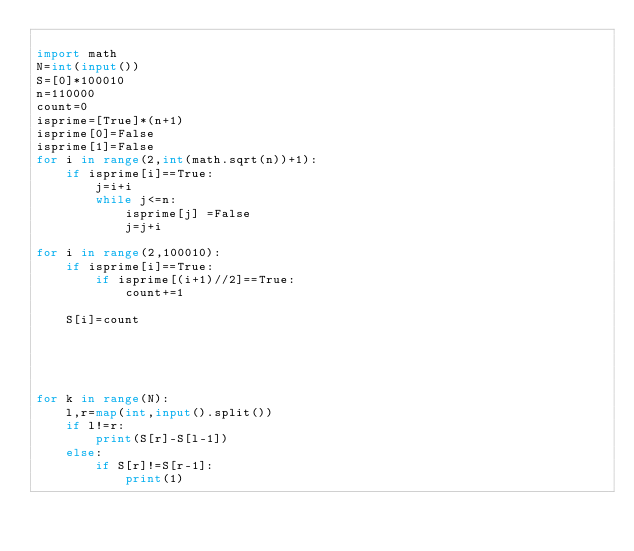<code> <loc_0><loc_0><loc_500><loc_500><_Python_>
import math
N=int(input())
S=[0]*100010
n=110000
count=0
isprime=[True]*(n+1)
isprime[0]=False
isprime[1]=False
for i in range(2,int(math.sqrt(n))+1):
    if isprime[i]==True:
        j=i+i
        while j<=n:
            isprime[j] =False
            j=j+i

for i in range(2,100010):
    if isprime[i]==True:
        if isprime[(i+1)//2]==True:
            count+=1
    
    S[i]=count
        
                
    

    
for k in range(N):
    l,r=map(int,input().split())
    if l!=r:
        print(S[r]-S[l-1])
    else:
        if S[r]!=S[r-1]:
            print(1)</code> 